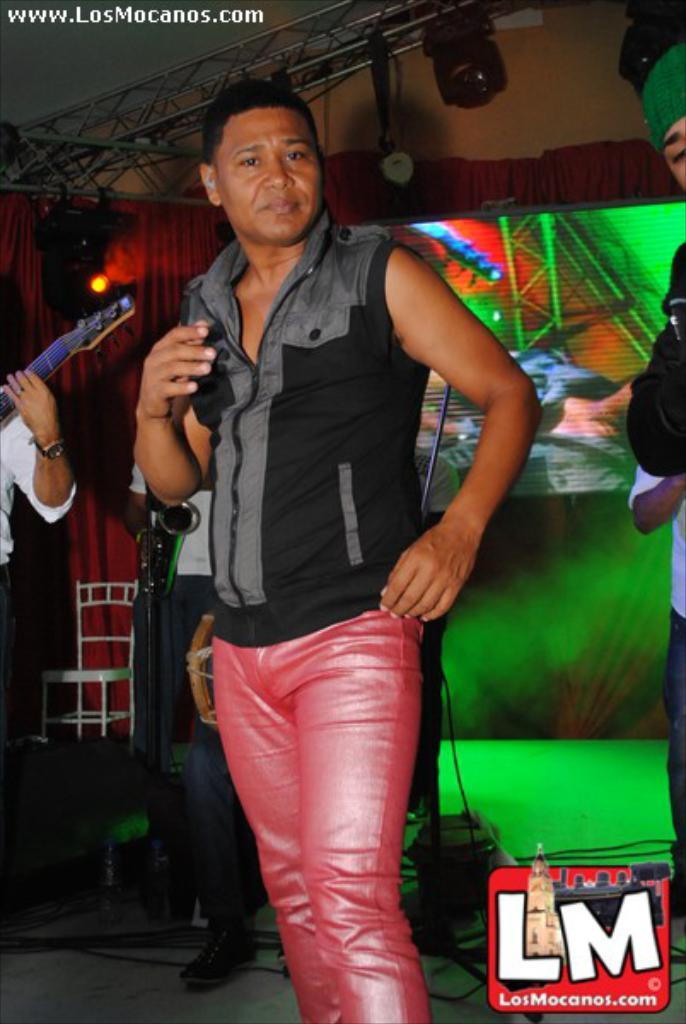What is the main subject of the image? The main subject of the image is a man. What is the man wearing in the image? The man is wearing a black t-shirt in the image. Can you describe any other details about the image? There is a mark on the right side of the image. What type of flag is being waved by the man in the image? There is no flag present in the image, and the man is not waving anything. Can you tell me how many bikes are visible in the image? There are no bikes visible in the image; the main subject is a man wearing a black t-shirt. 